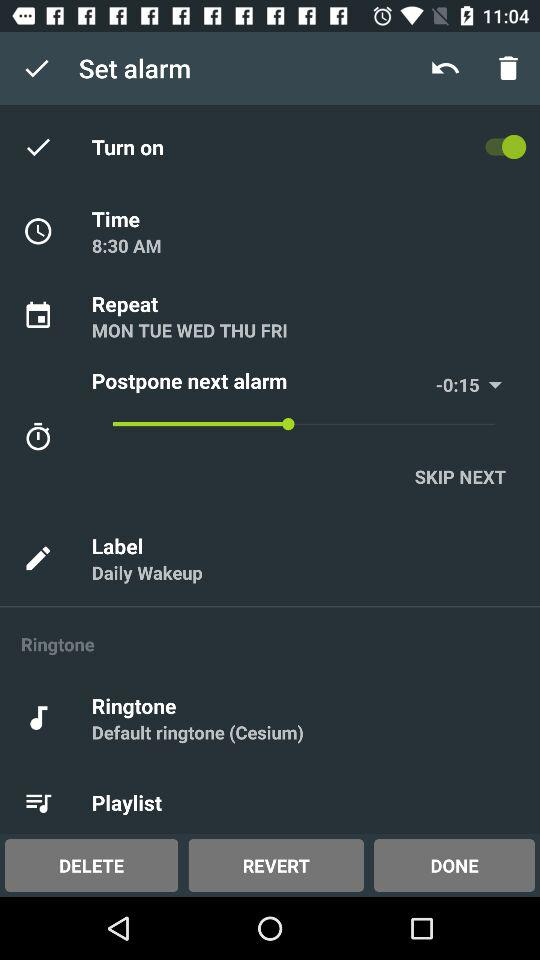What is the time shown? The time shown is 8:30 AM. 